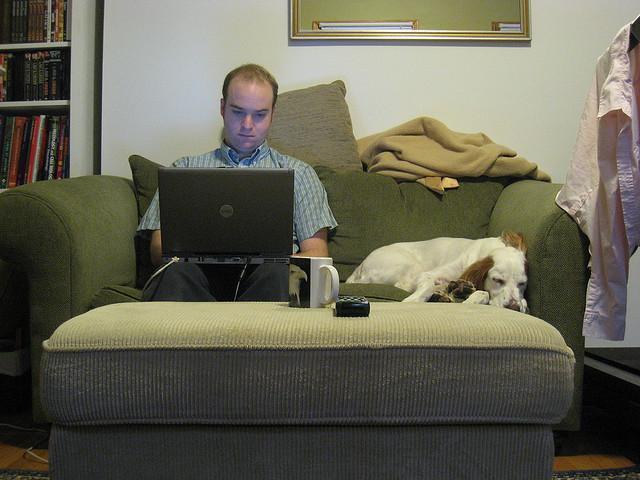How many cats are shown?
Give a very brief answer. 0. How many books can you see?
Give a very brief answer. 2. How many black motorcycles are there?
Give a very brief answer. 0. 